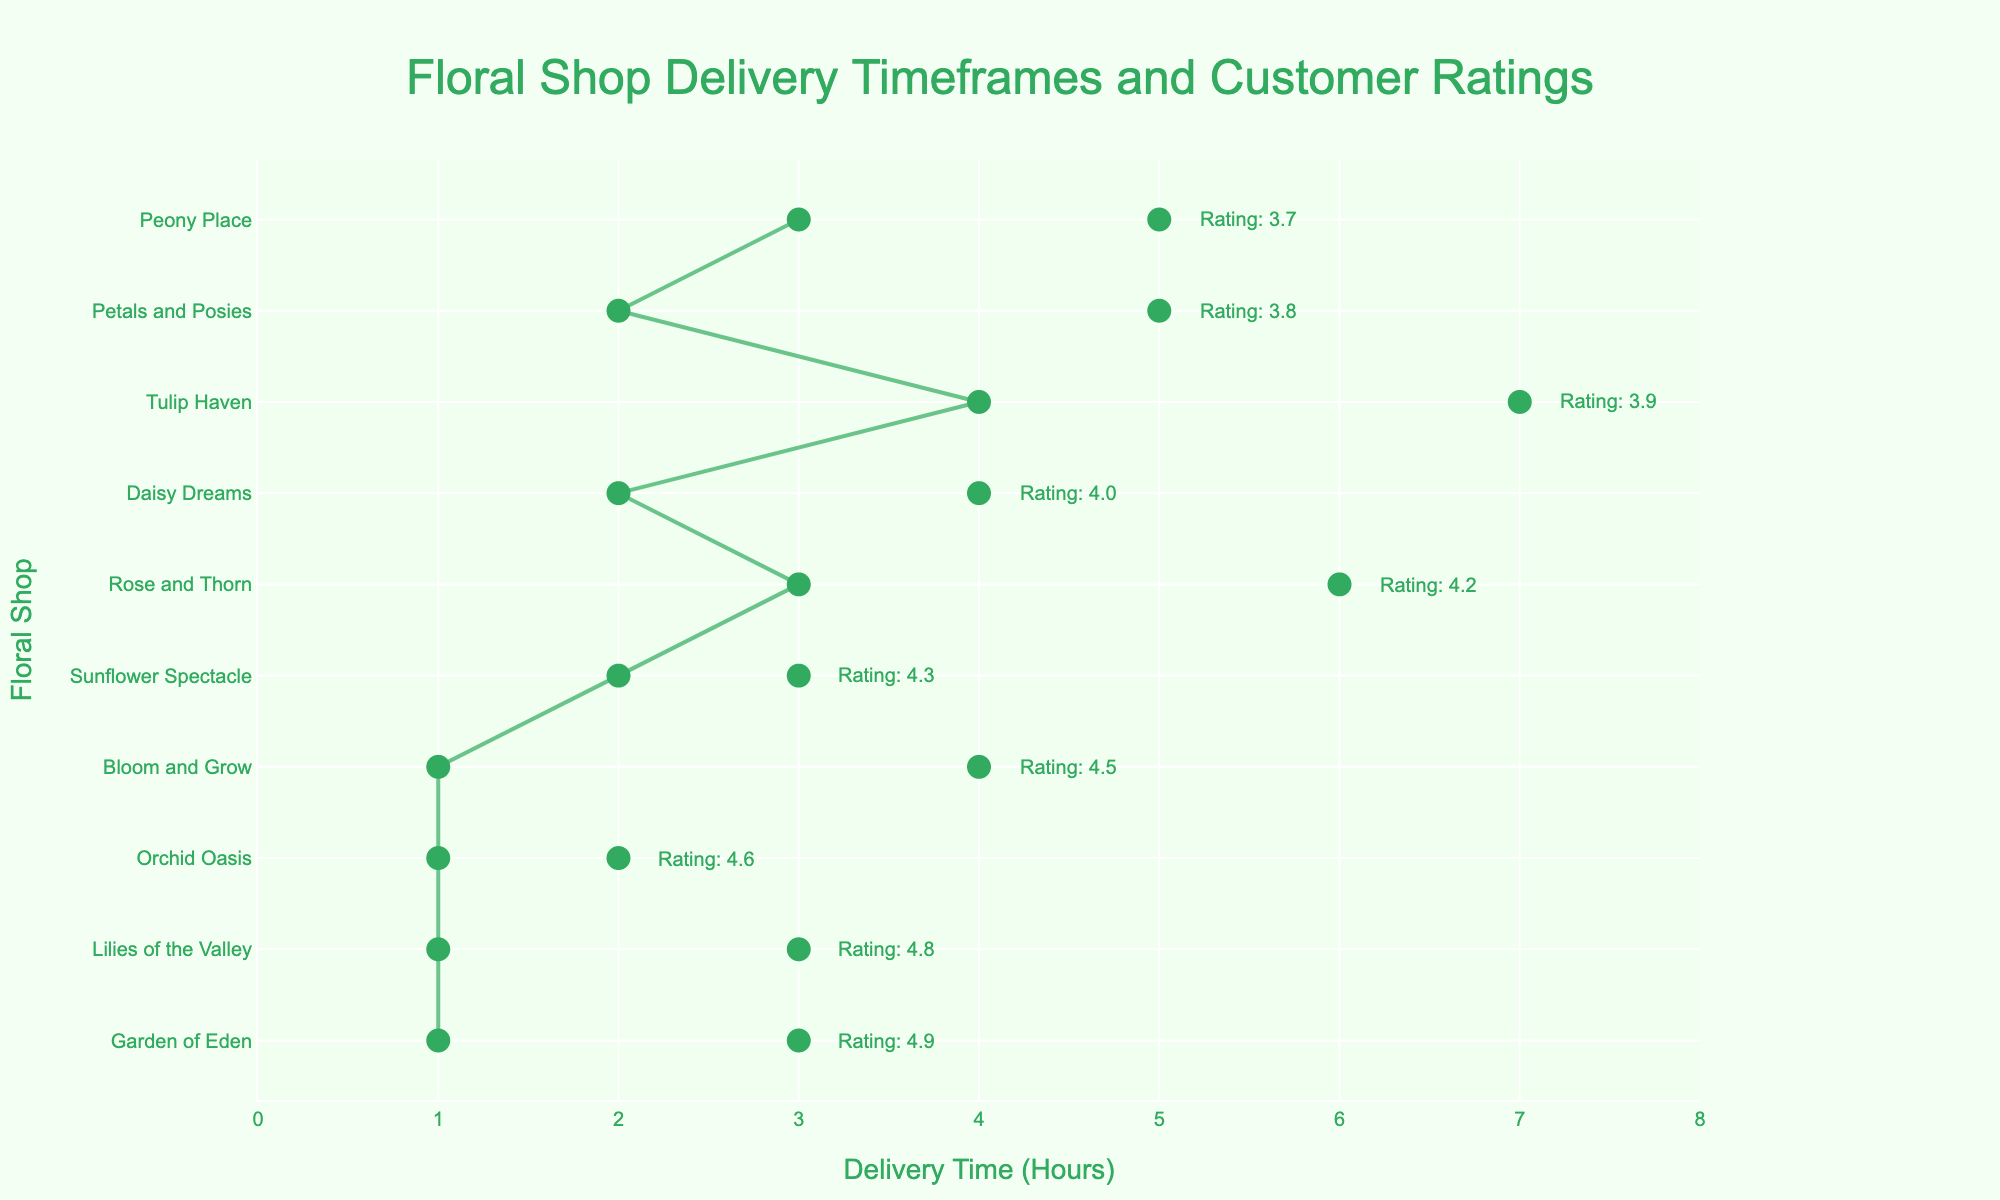What's the title of the plot? The title is typically shown at the top of the plot. In this case, the title is displayed as 'Floral Shop Delivery Timeframes and Customer Ratings'
Answer: Floral Shop Delivery Timeframes and Customer Ratings Which floral shop has the highest customer rating? The highest customer rating can be found by looking at the annotation text next to the highest plotted line on the y-axis. According to the plot, 'Garden of Eden' has the highest rating of 4.9.
Answer: Garden of Eden What is the minimum delivery time range among all floral shops? To find the minimum delivery time range, we look at the difference between the minimum and maximum delivery times for each shop. The smallest range is for 'Orchid Oasis', which has a range from 1 to 2 hours.
Answer: 1 hour How many floral shops have customer ratings above 4.0? To count the floral shops with ratings above 4.0, we refer to the annotations next to each shop. The shops 'Bloom and Grow', 'Lilies of the Valley', 'Rose and Thorn', 'Daisy Dreams', 'Orchid Oasis', 'Sunflower Spectacle', and 'Garden of Eden' all meet this criterion.
Answer: 7 Which floral shop has the broadest delivery time range? The broadest delivery range can be found by looking at the range between the minimum and maximum delivery times for each shop. 'Tulip Haven' has the broadest range, from 4 to 7 hours.
Answer: Tulip Haven What's the average of the maximum delivery times for all floral shops? Sum all the maximum delivery times and divide by the number of floral shops: (4 + 5 + 3 + 6 + 4 + 7 + 2 + 3 + 5 + 3) / 10 = 42/10 = 4.2.
Answer: 4.2 hours Which floral shop has a lower minimum delivery time, 'Bloom and Grow' or 'Rose and Thorn'? Compare the minimum delivery times of 'Bloom and Grow' (1 hour) and 'Rose and Thorn' (3 hours). 'Bloom and Grow' has a lower minimum delivery time.
Answer: Bloom and Grow Is there any floral shop with a minimum delivery time of 3 hours? Look for floral shops with 3 hours as their minimum delivery time by checking the plot. Both 'Rose and Thorn' and 'Peony Place' have a minimum delivery time of 3 hours.
Answer: Yes What is the customer rating of 'Sunflower Spectacle'? Refer to the annotation next to 'Sunflower Spectacle' on the y-axis. The rating shown is 4.3.
Answer: 4.3 Which floral shop immediately follows 'Daisy Dreams' on customer ratings? 'Daisy Dreams' has a rating of 4.0. The next shop with a slightly lower rating is 'Tulip Haven', with a rating of 3.9.
Answer: Tulip Haven 